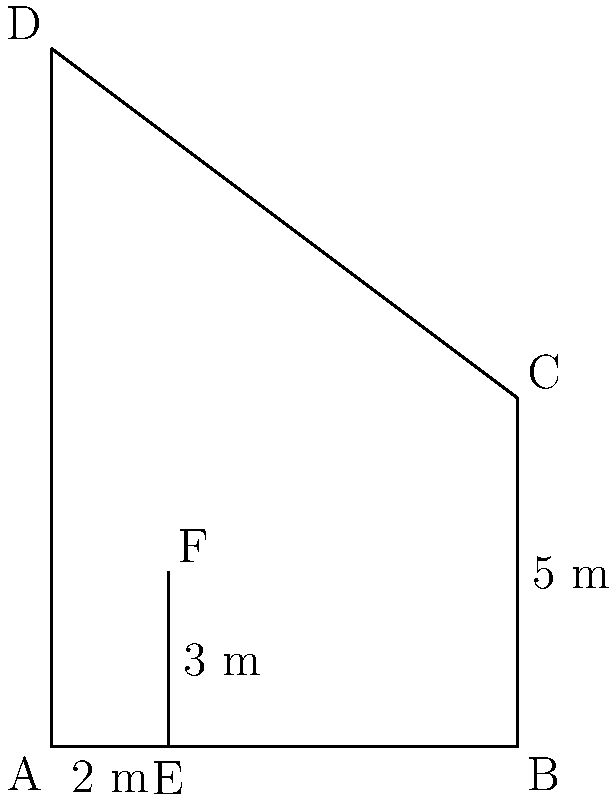At a historical site in Southeast Asia, you're explaining to tourists how ancient architects used simple geometry to design pagodas. You demonstrate this concept using the shadow of a nearby pagoda. If a 2-meter stick casts a 3-meter shadow, and the pagoda's shadow is 6 meters long, what is the height of the pagoda? Let's approach this step-by-step using the principle of similar triangles:

1) We have two similar triangles:
   - The smaller triangle formed by the stick and its shadow
   - The larger triangle formed by the pagoda and its shadow

2) In the smaller triangle:
   - The stick height is 2 meters
   - The shadow length is 3 meters

3) In the larger triangle:
   - The pagoda shadow length is 6 meters
   - The pagoda height is what we need to find, let's call it $h$

4) Since the triangles are similar, their ratios are equal:

   $$\frac{\text{stick height}}{\text{stick shadow}} = \frac{\text{pagoda height}}{\text{pagoda shadow}}$$

5) Substituting the known values:

   $$\frac{2}{3} = \frac{h}{6}$$

6) Cross multiply:

   $$2 \cdot 6 = 3 \cdot h$$
   $$12 = 3h$$

7) Solve for $h$:

   $$h = \frac{12}{3} = 4$$

Therefore, the height of the pagoda is 4 meters.
Answer: 4 meters 